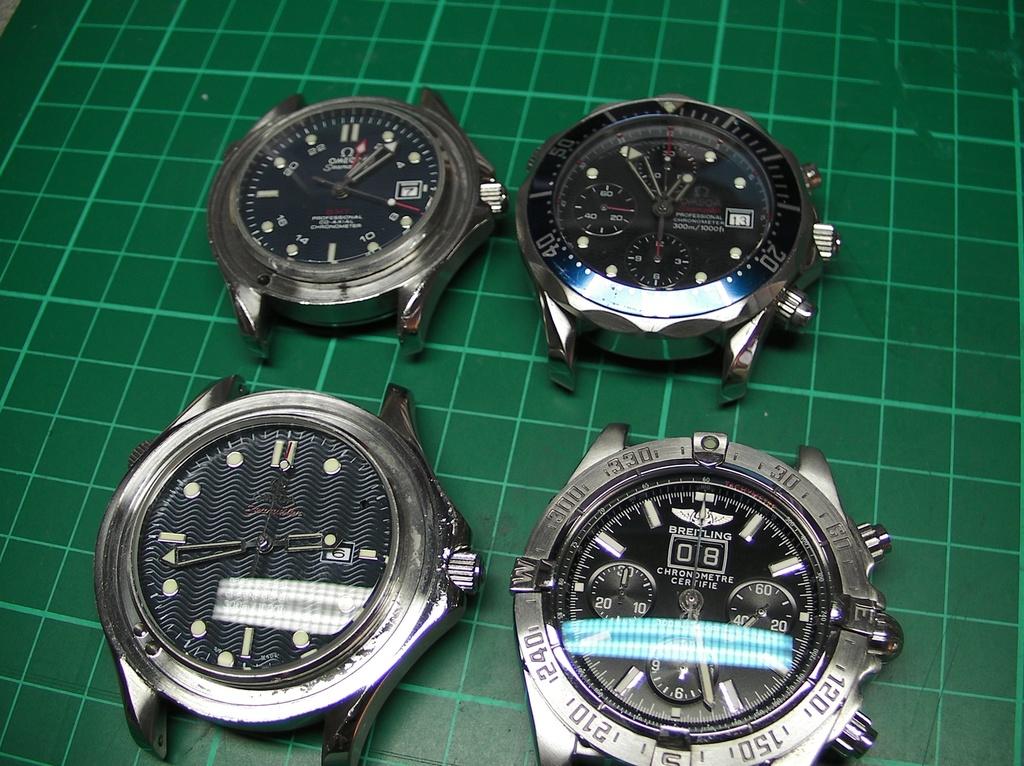What is the time displayed on the top left watch?
Provide a succinct answer. 1:07. What is the time on the 1st watch top left?
Ensure brevity in your answer.  1:07. 